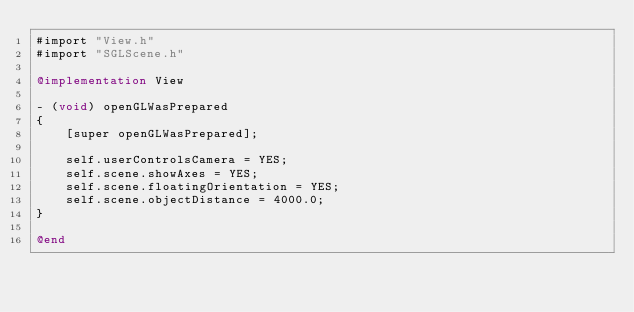Convert code to text. <code><loc_0><loc_0><loc_500><loc_500><_ObjectiveC_>#import "View.h"
#import "SGLScene.h"

@implementation View

- (void) openGLWasPrepared
{
    [super openGLWasPrepared];
    
    self.userControlsCamera = YES;
    self.scene.showAxes = YES;
    self.scene.floatingOrientation = YES;
    self.scene.objectDistance = 4000.0;
}

@end
</code> 